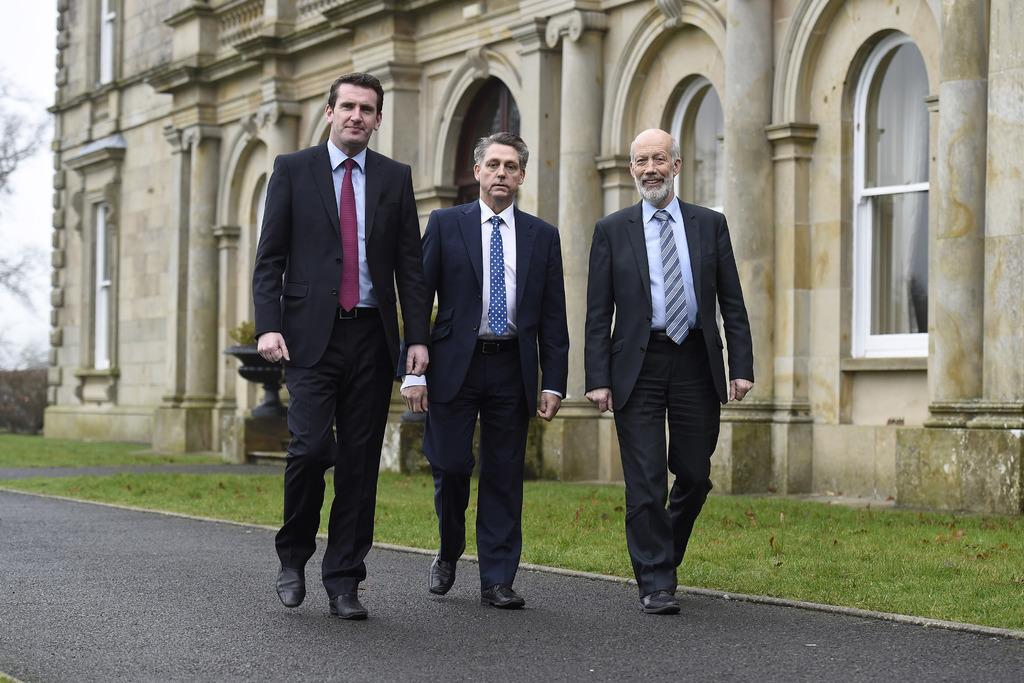What is located in the background of the image? There is a building in the background of the image. What is at the bottom of the image? There is a road at the bottom of the image. What type of vegetation is present on the ground? There is grass on the ground. Can you describe the people in the image? The provided facts do not mention any specific details about the people in the image. What type of amusement can be seen in the image? There is no amusement present in the image; it features a building, a road, and grass. How many attempts are being made by the persons in the image? The provided facts do not mention any specific details about the people in the image, so it is impossible to determine if they are making any attempts. 